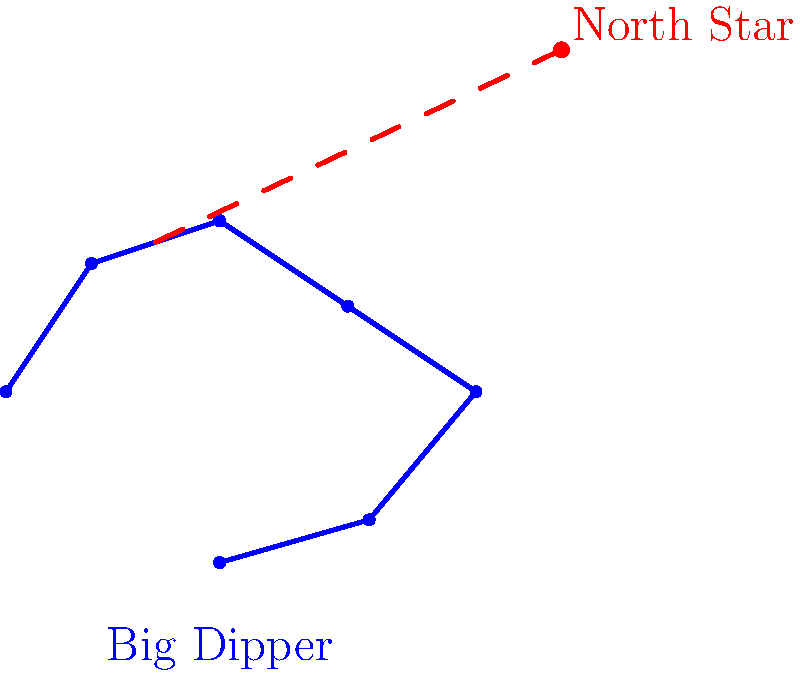When using the Big Dipper for navigation during a night hunt, how many times the distance between the two "pointer stars" should you measure to locate the North Star? To locate the North Star using the Big Dipper constellation, follow these steps:

1. Identify the Big Dipper constellation in the night sky. It consists of seven bright stars forming a shape resembling a large ladle or dipper.

2. Locate the two stars at the front edge of the Big Dipper's "bowl". These are called the "pointer stars".

3. Draw an imaginary line connecting these two pointer stars.

4. Extend this imaginary line outward from the Big Dipper's bowl.

5. Measure the distance between the two pointer stars.

6. From the outermost pointer star, measure approximately 5 times the distance between the pointer stars along the imaginary line.

7. At this point, you should find the North Star (Polaris), which is the last star in the handle of the Little Dipper constellation.

The key is to remember that the distance to measure is about 5 times the space between the pointer stars. This method provides a reliable way to locate the North Star for navigation in remote areas, even when other landmarks are not visible.
Answer: 5 times 